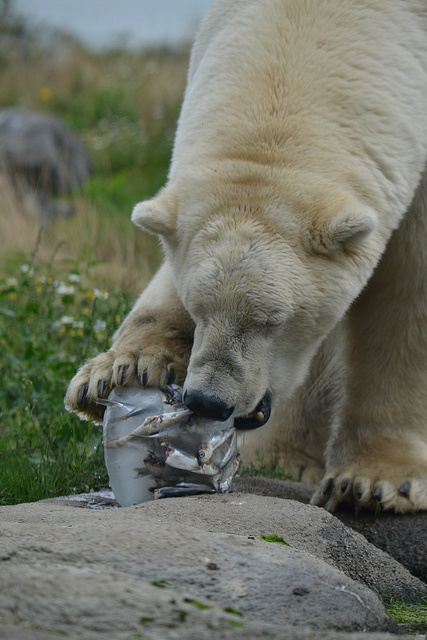Describe the objects in this image and their specific colors. I can see a bear in gray, darkgray, and black tones in this image. 